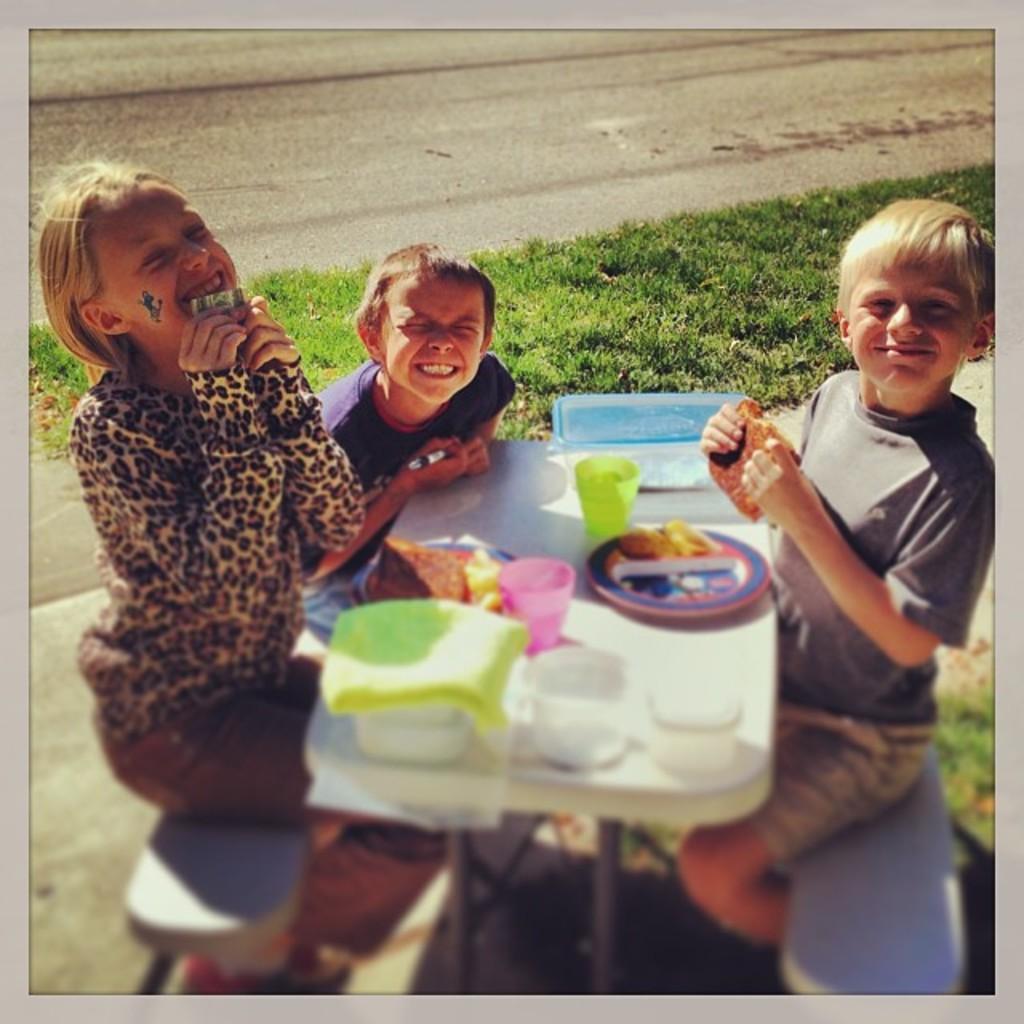Could you give a brief overview of what you see in this image? This image is clicked outside. there is grass in the middle. There is a table and two benches on the table there is a plate, glass, box, eatables. There are three children sitting around the table one is girl she is on the left side and 2 are boys. All of them are smiling. 